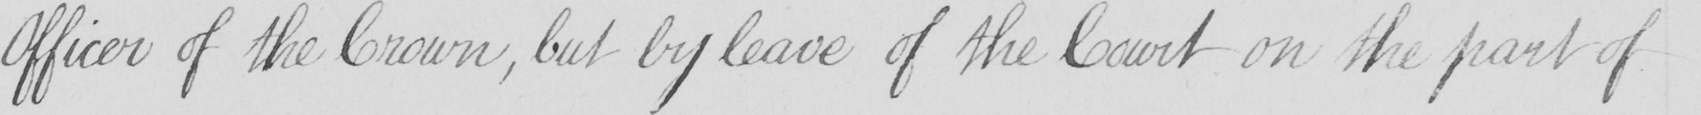Can you tell me what this handwritten text says? Officer of the Crown , but by leave of the Court on the part of 